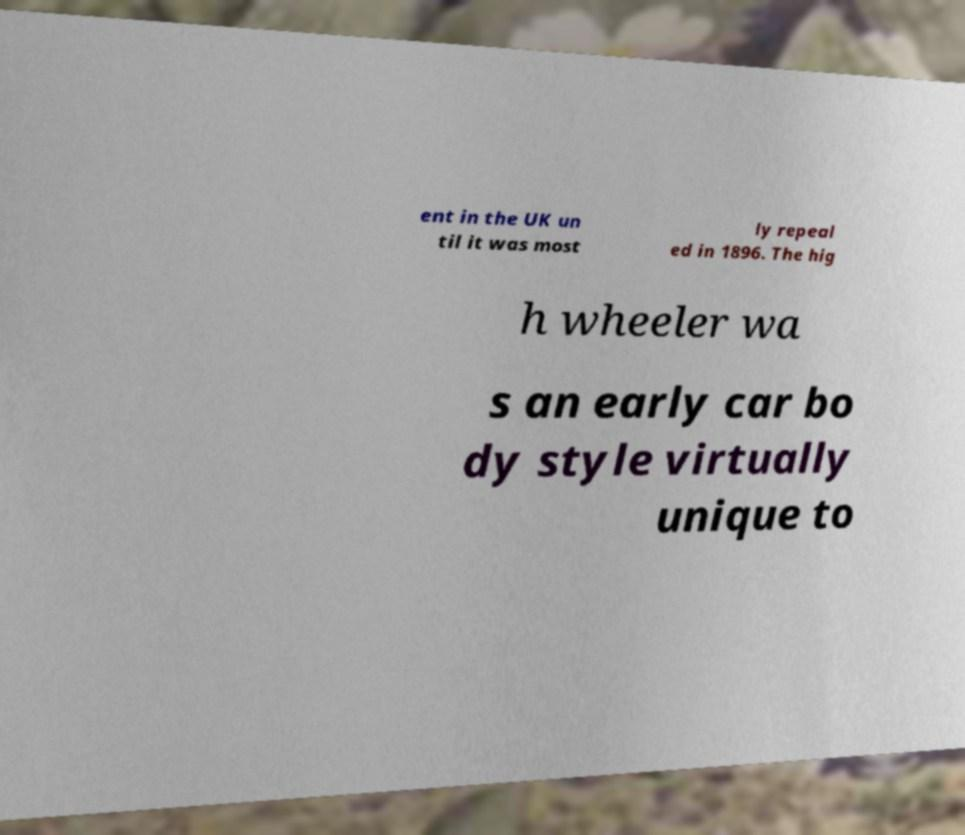For documentation purposes, I need the text within this image transcribed. Could you provide that? ent in the UK un til it was most ly repeal ed in 1896. The hig h wheeler wa s an early car bo dy style virtually unique to 